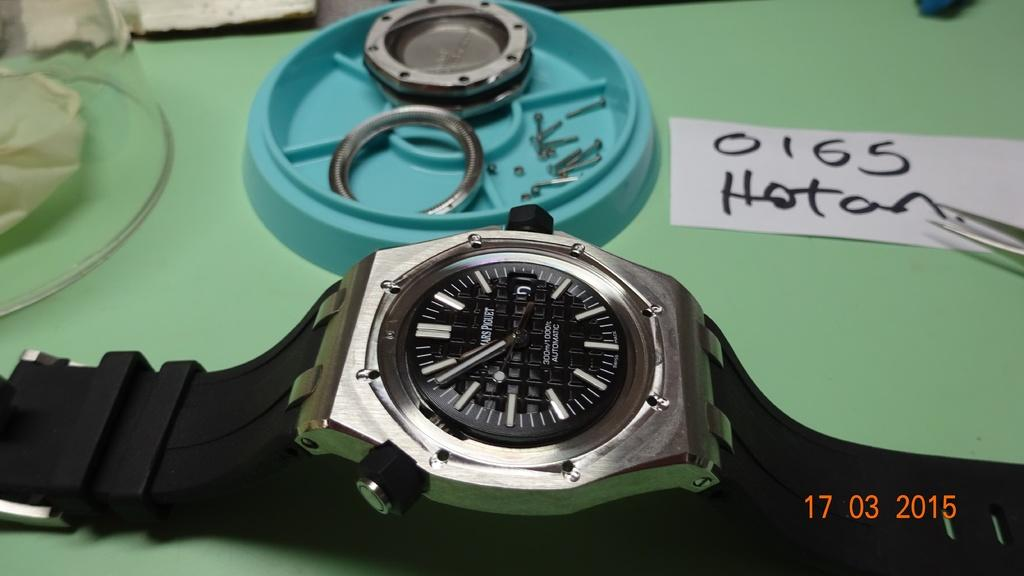<image>
Provide a brief description of the given image. A picture of a watch that was taken on March 17, 2015. 